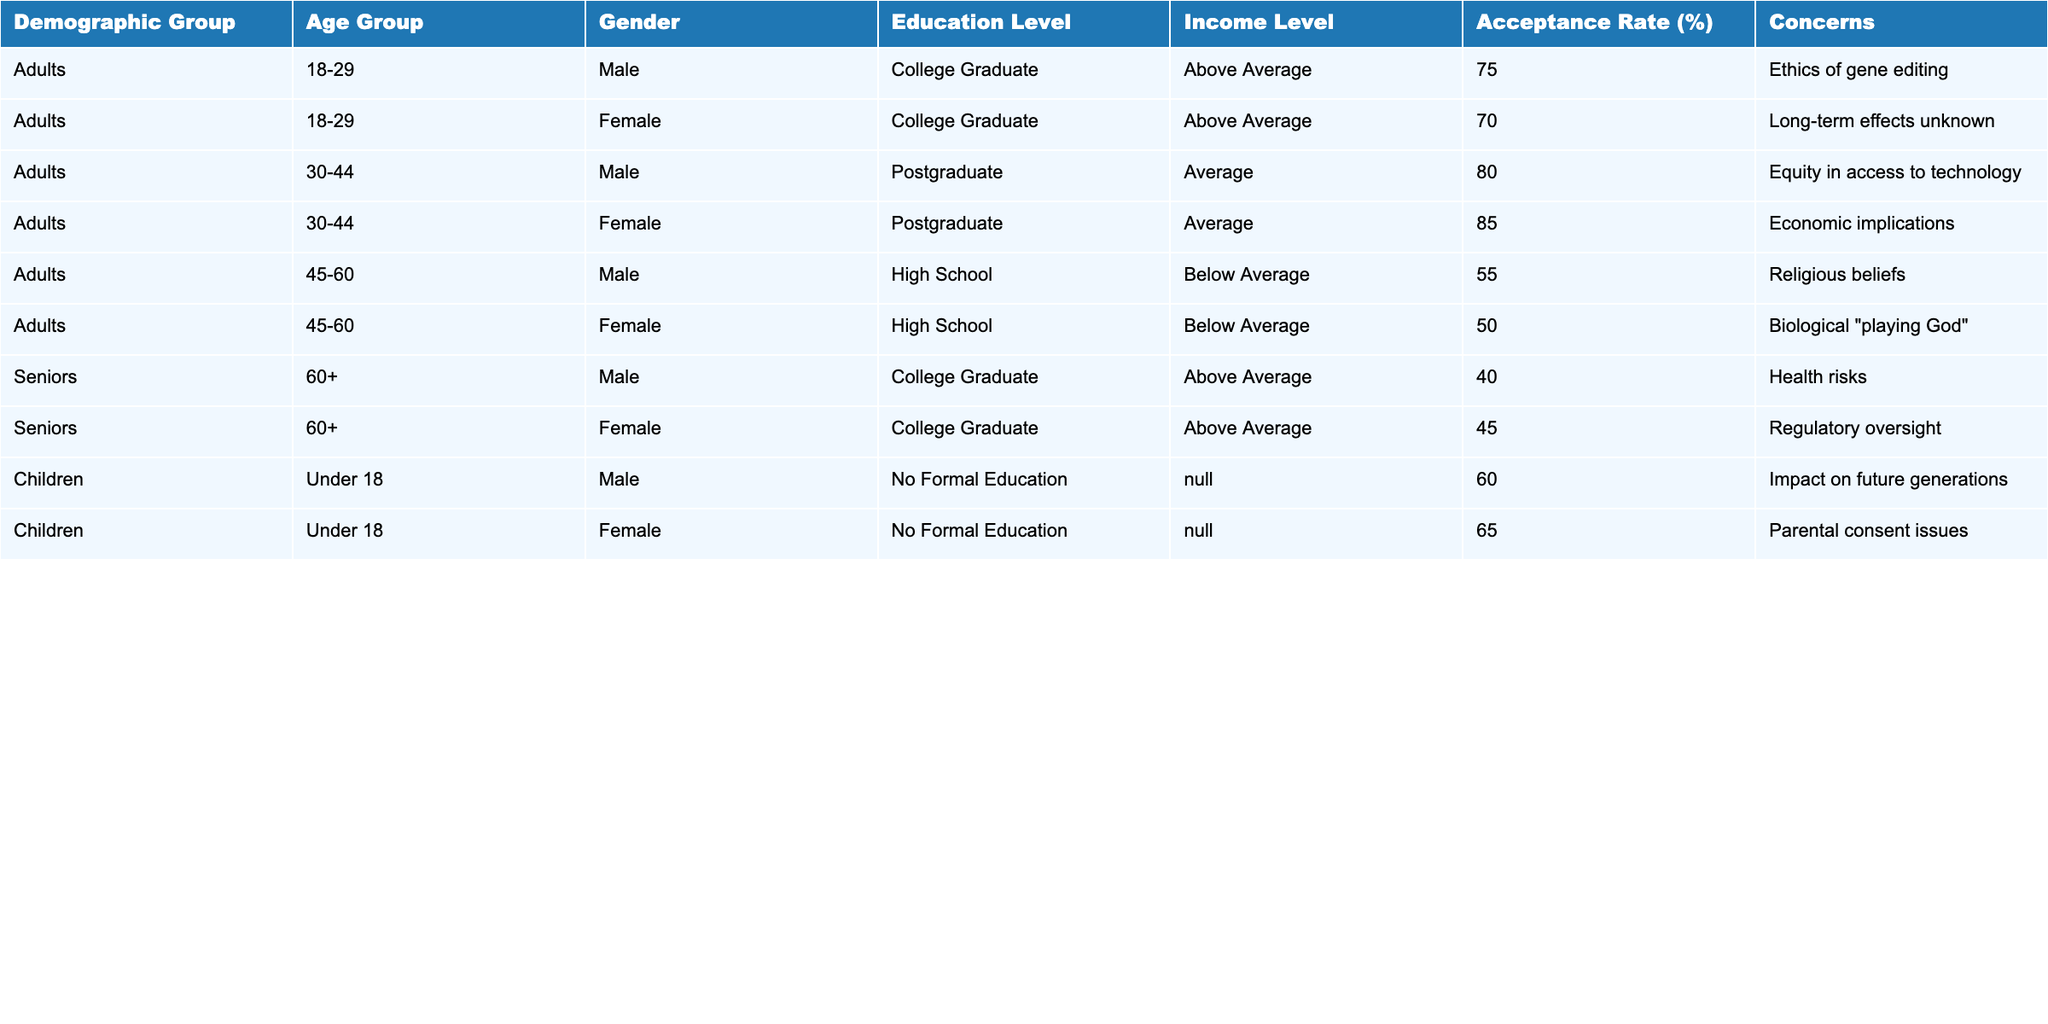What is the acceptance rate for males aged 30-44? The acceptance rate for males in this age group is specifically mentioned in the table, which states it as 80%.
Answer: 80% What concerns do females aged 30-44 have regarding CRISPR technology? The table indicates that females in this age group are mainly concerned about economic implications.
Answer: Economic implications Which demographic group has the highest acceptance rate? By comparing the acceptance rates of all groups, females aged 30-44 have the highest acceptance rate at 85%.
Answer: 85% What is the average acceptance rate for seniors aged 60 and over? The acceptance rates for seniors are 40% for males and 45% for females. Calculating the average: (40 + 45) / 2 = 42.5%.
Answer: 42.5% Is there concern about the long-term effects of gene editing among any group? Yes, females aged 18-29 specifically cite long-term effects as a concern.
Answer: Yes How does the acceptance rate for children compare to seniors? Children have an acceptance rate of 60% (for both genders combined) while seniors have an average of 42.5%. Since 60% is greater than 42.5%, children have a higher acceptance rate.
Answer: Higher acceptance rate for children What is the overall trend in acceptance rates as age increases? By examining the acceptance rates across the different age groups, it appears that acceptance decreases as age increases - adults generally have higher rates than seniors.
Answer: Acceptance decreases with age Which educational level corresponds to the highest acceptance rate? Referring to educational levels, postgraduate adults aged 30-44 have the highest acceptance rate at 85%.
Answer: Postgraduate What percentage of the female demographic aged 45-60 have concerns about religious beliefs? According to the table, females aged 45-60 express concerns about biological "playing God," which reflects the underlying religious belief systems.
Answer: 50% What is the difference in acceptance rates between adults aged 18-29 and seniors aged 60+? Adults aged 18-29 have an average acceptance rate of 72.5% (since 75% for males and 70% for females) and seniors have an average acceptance rate of 42.5%. The difference is 72.5% - 42.5% = 30%.
Answer: 30% 